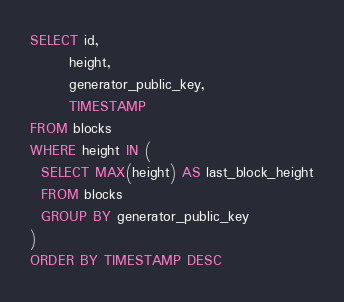Convert code to text. <code><loc_0><loc_0><loc_500><loc_500><_SQL_>SELECT id,
       height,
       generator_public_key,
       TIMESTAMP
FROM blocks
WHERE height IN (
  SELECT MAX(height) AS last_block_height
  FROM blocks
  GROUP BY generator_public_key
)
ORDER BY TIMESTAMP DESC
</code> 